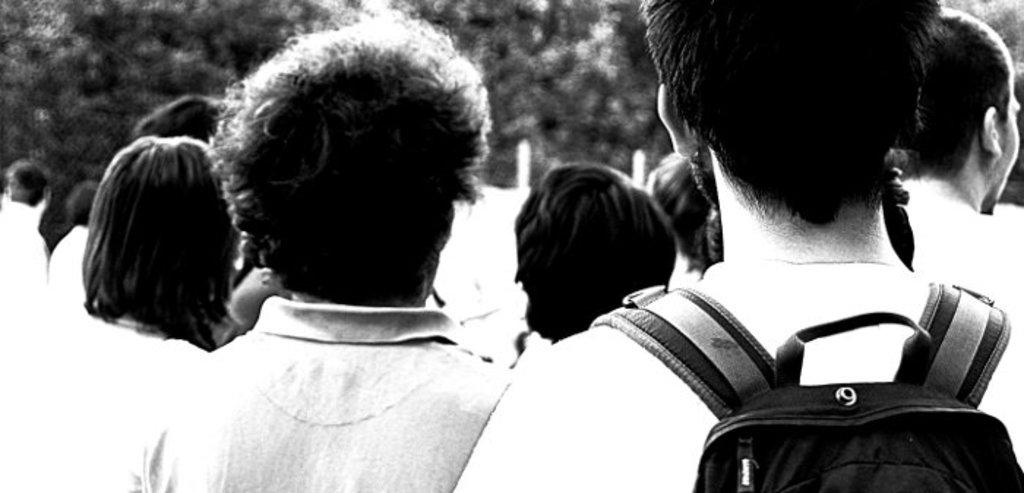What is the color scheme of the image? The image is black and white. Can you describe the subjects in the image? There are people in the image. What type of visual effect is present in the image? There is an illusion of trees in the image. What type of record can be seen playing in the image? There is no record present in the image. How does the sleet affect the people in the image? There is no sleet present in the image; it is a black and white image with people and an illusion of trees. 